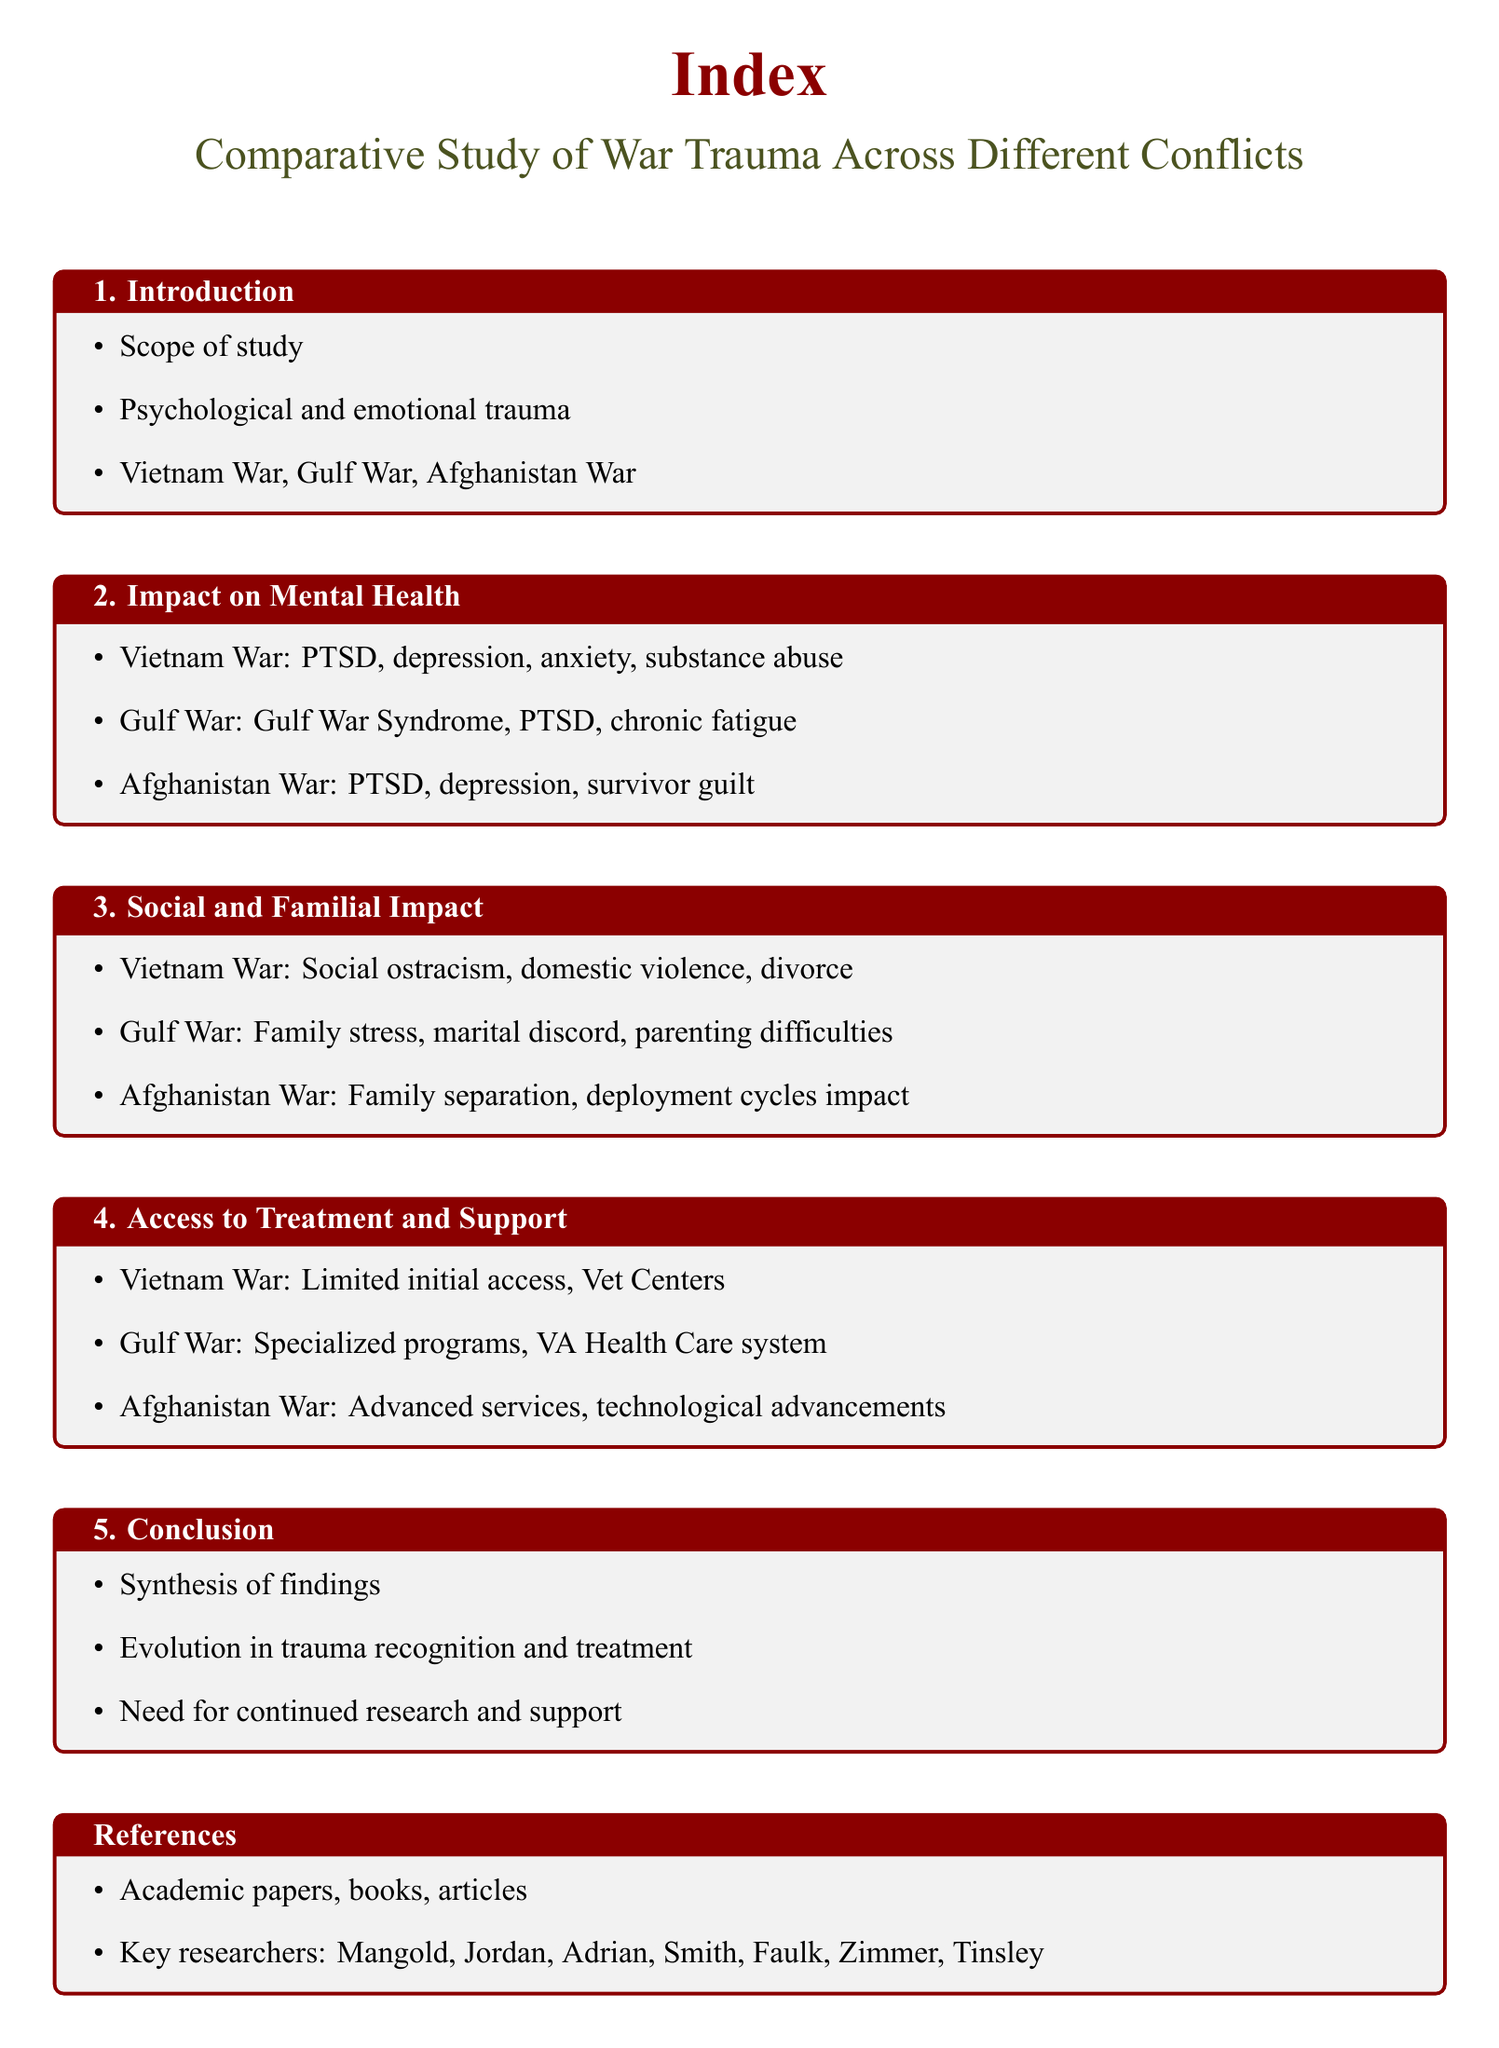What are the three wars compared in this study? The document lists the Vietnam War, Gulf War, and Afghanistan War as the three conflicts being compared.
Answer: Vietnam War, Gulf War, Afghanistan War What mental health issues are associated with the Afghanistan War? The issues mentioned include PTSD, depression, and survivor guilt as linked to the Afghanistan War.
Answer: PTSD, depression, survivor guilt What significant impact did the Vietnam War have on families? The document states that social ostracism, domestic violence, and divorce were significant impacts of the Vietnam War.
Answer: Social ostracism, domestic violence, divorce Which war is associated with Gulf War Syndrome? The Gulf War is specifically linked to Gulf War Syndrome according to the document.
Answer: Gulf War What advancements were made in treatment access by the Afghanistan War? The document indicates that advanced services and technological advancements improved access to treatment during the Afghanistan War.
Answer: Advanced services, technological advancements How does the document categorize its findings? The findings are synthesized in the conclusion section, summarizing the various impacts of war trauma.
Answer: Synthesis of findings What key researchers are mentioned in the references? The document lists key researchers such as Mangold, Jordan, Adrian, Smith, Faulk, Zimmer, and Tinsley.
Answer: Mangold, Jordan, Adrian, Smith, Faulk, Zimmer, Tinsley What type of trauma effects were noted for the Gulf War? The Gulf War is noted for issues such as Gulf War Syndrome, PTSD, and chronic fatigue.
Answer: Gulf War Syndrome, PTSD, chronic fatigue What aspect of post-war life is addressed under "Social and Familial Impact"? The document discusses family stress, marital discord, and parenting difficulties associated with the Gulf War under this section.
Answer: Family stress, marital discord, parenting difficulties 